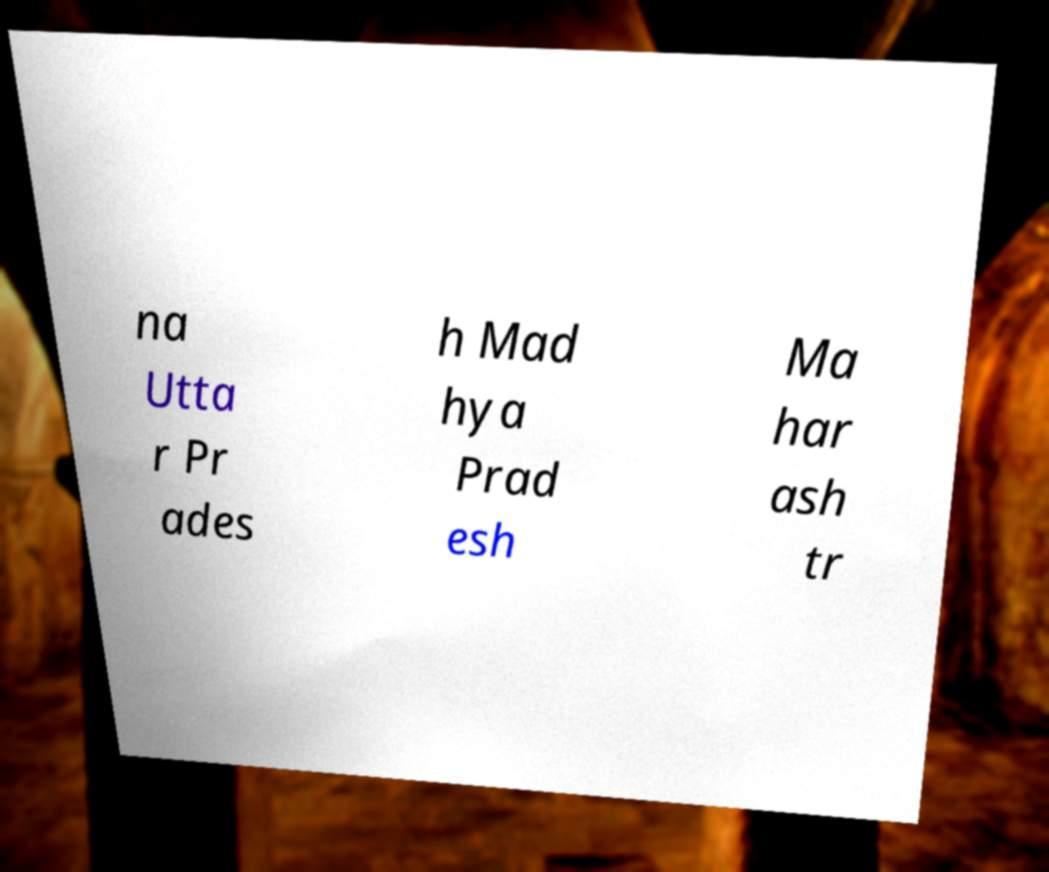Can you read and provide the text displayed in the image?This photo seems to have some interesting text. Can you extract and type it out for me? na Utta r Pr ades h Mad hya Prad esh Ma har ash tr 